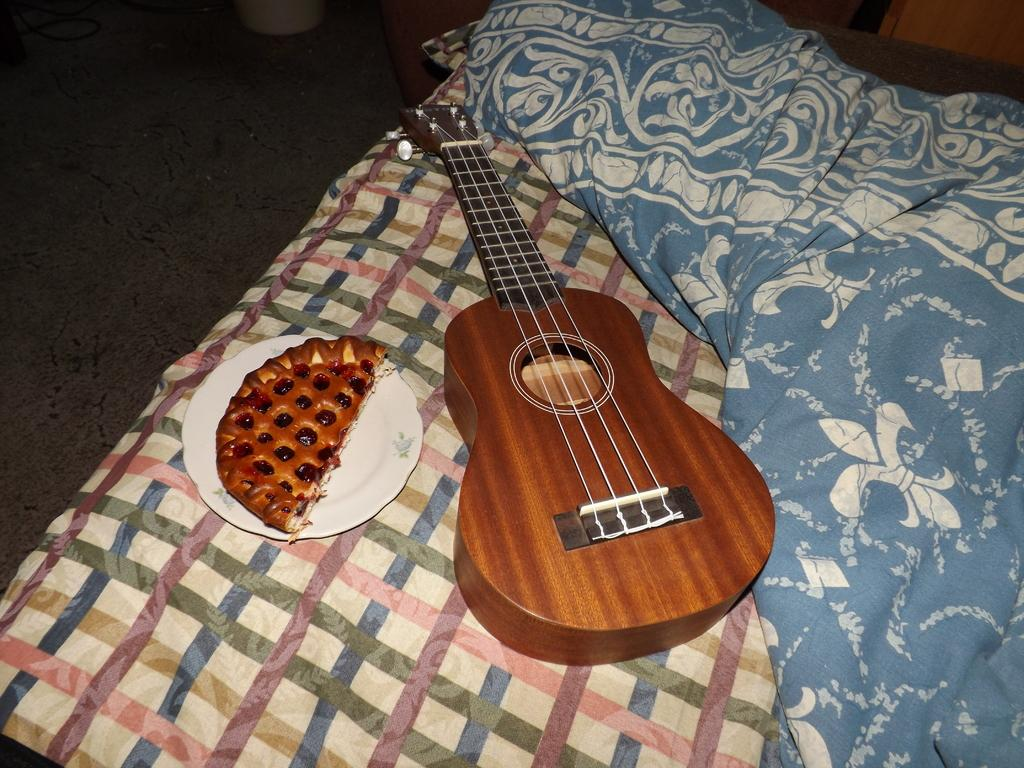What musical instrument is on the bed in the image? There is a guitar on the bed in the image. What type of object is not related to music but is present in the image? There is a plate of food in the image. What type of bird is sitting on the clover in the image? There is no bird or clover present in the image. What does the guitar need to play music in the image? The guitar itself does not need anything to play music in the image, as it is an inanimate object. However, a person would need to play it to produce music. 